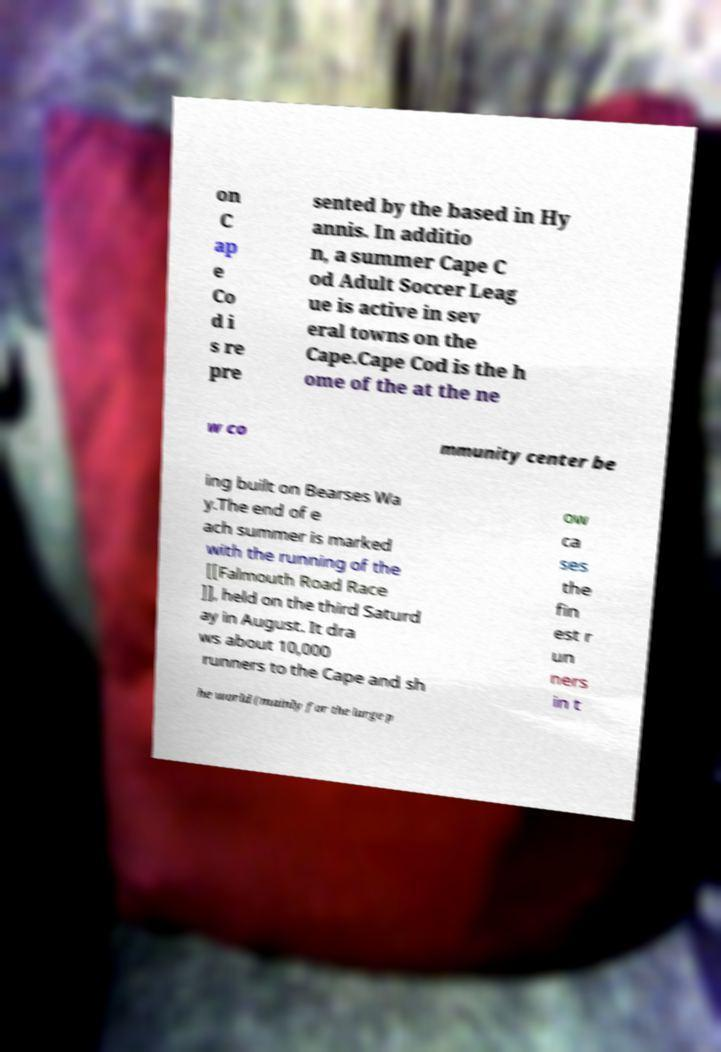Can you accurately transcribe the text from the provided image for me? on C ap e Co d i s re pre sented by the based in Hy annis. In additio n, a summer Cape C od Adult Soccer Leag ue is active in sev eral towns on the Cape.Cape Cod is the h ome of the at the ne w co mmunity center be ing built on Bearses Wa y.The end of e ach summer is marked with the running of the [[Falmouth Road Race ]], held on the third Saturd ay in August. It dra ws about 10,000 runners to the Cape and sh ow ca ses the fin est r un ners in t he world (mainly for the large p 